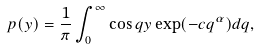Convert formula to latex. <formula><loc_0><loc_0><loc_500><loc_500>p ( y ) = \frac { 1 } { \pi } \int _ { 0 } ^ { \infty } \cos q y \exp ( - c q ^ { \alpha } ) d q ,</formula> 